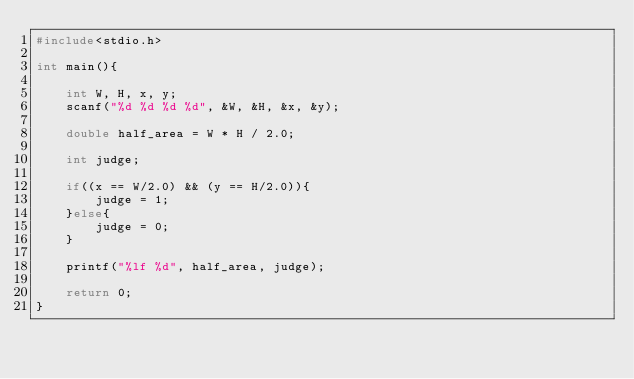Convert code to text. <code><loc_0><loc_0><loc_500><loc_500><_C_>#include<stdio.h>

int main(){

    int W, H, x, y;
    scanf("%d %d %d %d", &W, &H, &x, &y);

    double half_area = W * H / 2.0;

    int judge;

    if((x == W/2.0) && (y == H/2.0)){
        judge = 1;
    }else{
        judge = 0;
    }

    printf("%lf %d", half_area, judge);

    return 0;
}</code> 